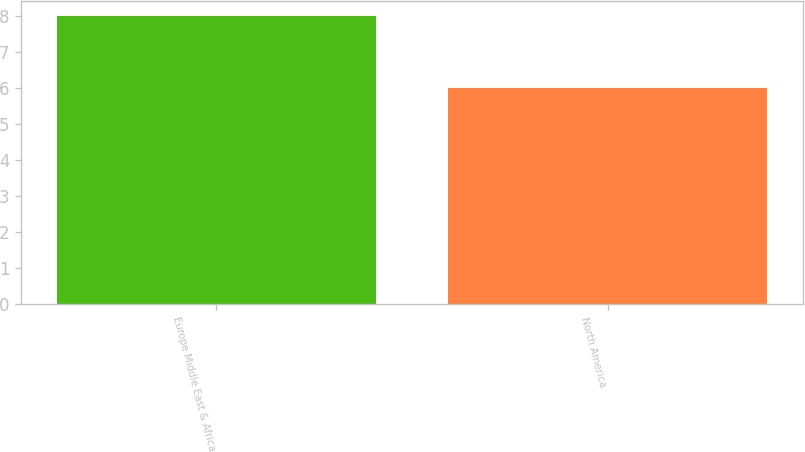Convert chart to OTSL. <chart><loc_0><loc_0><loc_500><loc_500><bar_chart><fcel>Europe Middle East & Africa<fcel>North America<nl><fcel>8<fcel>6<nl></chart> 